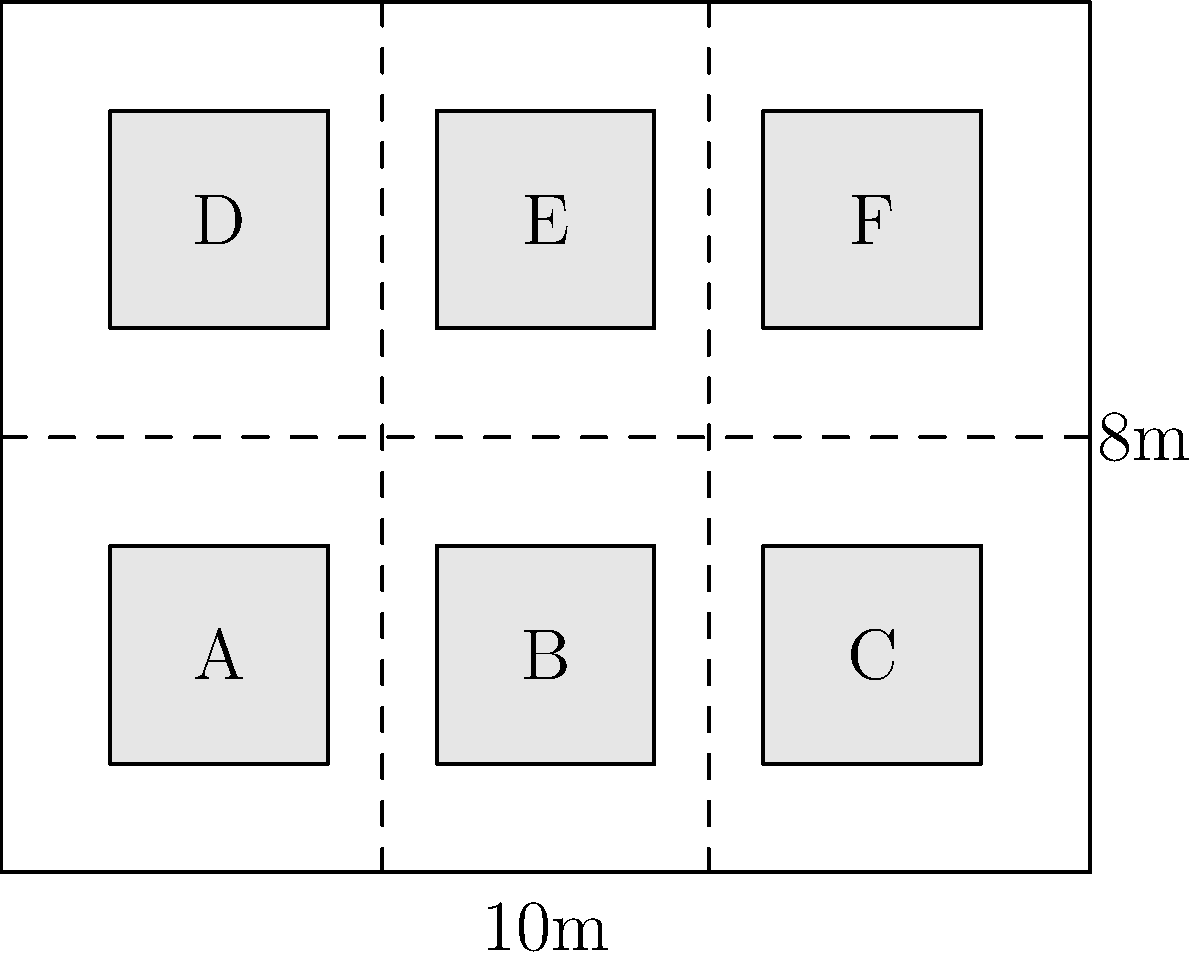In the warehouse layout shown above, there are six storage areas (A-F) separated by aisles. If each storage area can hold up to 1000 items and you need to store 4500 items, what is the minimum number of storage areas needed to efficiently organize the inventory while leaving the most contiguous empty space for future expansion? To solve this problem, we need to follow these steps:

1. Understand the given information:
   - There are 6 storage areas (A-F)
   - Each storage area can hold up to 1000 items
   - We need to store 4500 items

2. Calculate the minimum number of storage areas needed:
   - Number of areas = Ceiling(Total items / Capacity per area)
   - Number of areas = Ceiling(4500 / 1000) = 5

3. Consider the layout for efficient organization and future expansion:
   - Using 5 storage areas leaves 1 area empty for future expansion
   - To maximize contiguous empty space, we should use areas that are adjacent to each other

4. Determine the best arrangement:
   - Using areas A, B, C, D, and E leaves area F empty
   - This arrangement provides a large contiguous space for future expansion
   - It also allows for efficient movement of goods through the aisles

Therefore, the minimum number of storage areas needed to efficiently organize the inventory while leaving the most contiguous empty space for future expansion is 5.
Answer: 5 storage areas 